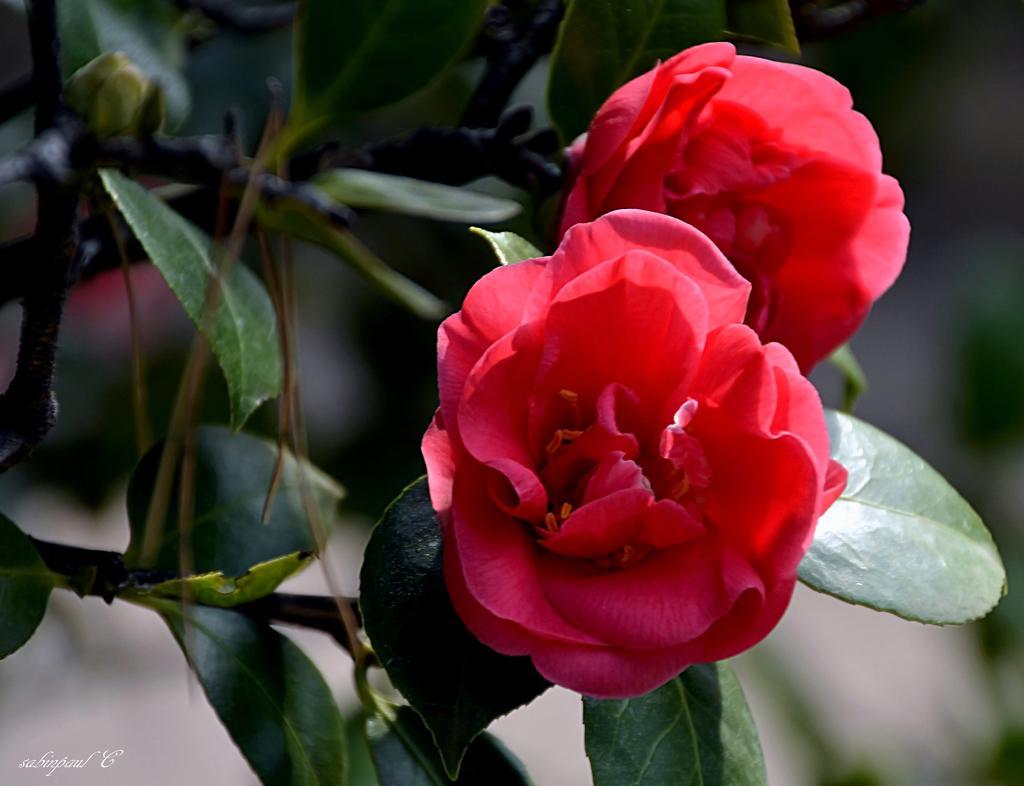In one or two sentences, can you explain what this image depicts? In this image I can see two flowers which are red in color to a plant which is green and brown in color and I can see the blurry background. 